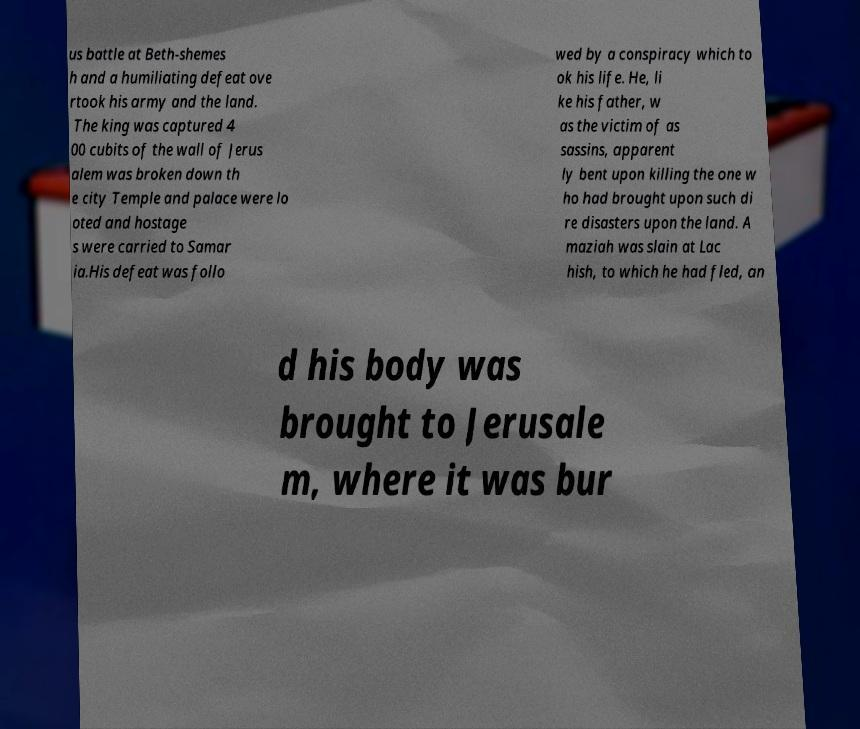Please read and relay the text visible in this image. What does it say? us battle at Beth-shemes h and a humiliating defeat ove rtook his army and the land. The king was captured 4 00 cubits of the wall of Jerus alem was broken down th e city Temple and palace were lo oted and hostage s were carried to Samar ia.His defeat was follo wed by a conspiracy which to ok his life. He, li ke his father, w as the victim of as sassins, apparent ly bent upon killing the one w ho had brought upon such di re disasters upon the land. A maziah was slain at Lac hish, to which he had fled, an d his body was brought to Jerusale m, where it was bur 